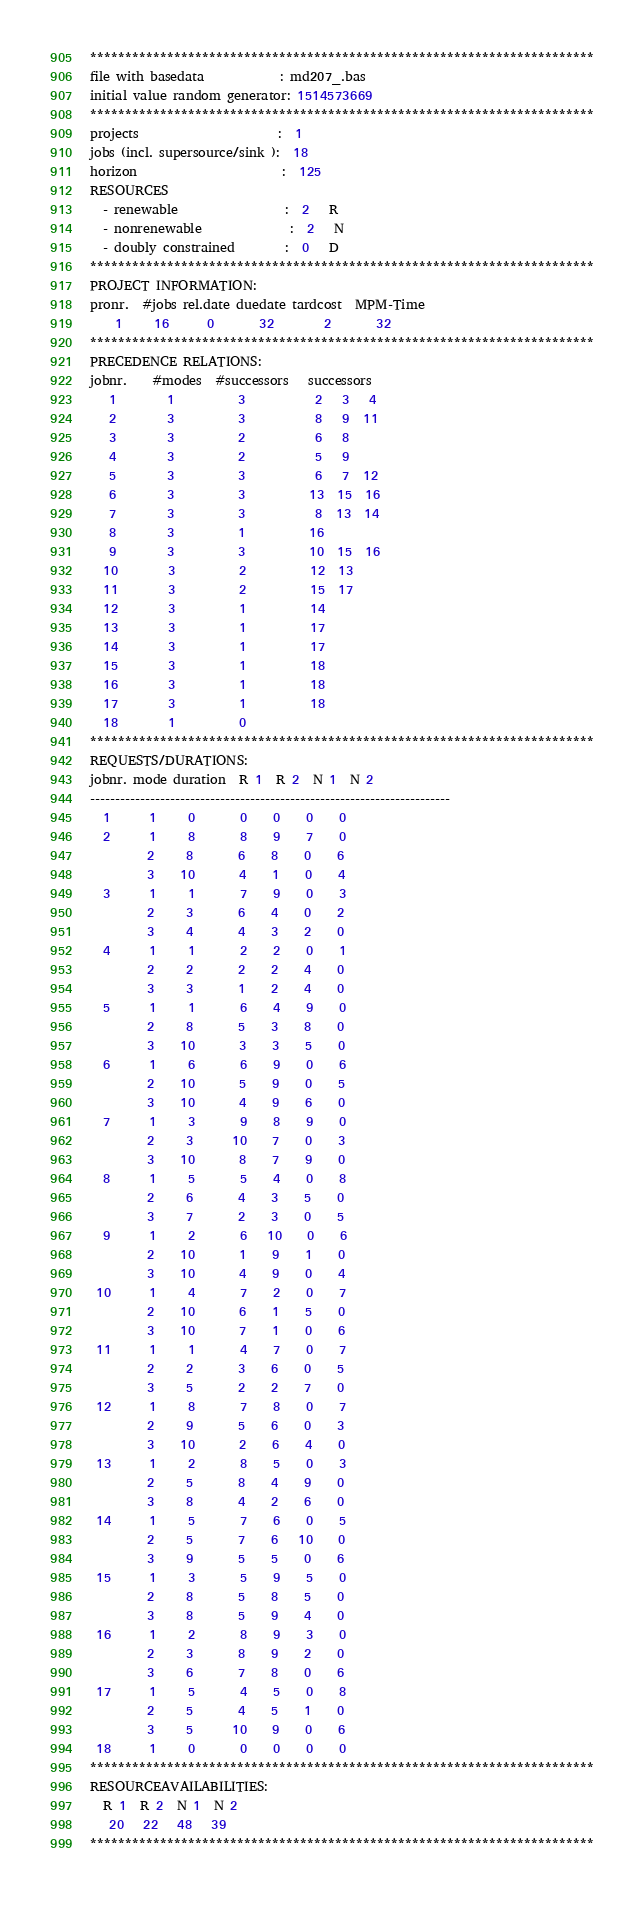<code> <loc_0><loc_0><loc_500><loc_500><_ObjectiveC_>************************************************************************
file with basedata            : md207_.bas
initial value random generator: 1514573669
************************************************************************
projects                      :  1
jobs (incl. supersource/sink ):  18
horizon                       :  125
RESOURCES
  - renewable                 :  2   R
  - nonrenewable              :  2   N
  - doubly constrained        :  0   D
************************************************************************
PROJECT INFORMATION:
pronr.  #jobs rel.date duedate tardcost  MPM-Time
    1     16      0       32        2       32
************************************************************************
PRECEDENCE RELATIONS:
jobnr.    #modes  #successors   successors
   1        1          3           2   3   4
   2        3          3           8   9  11
   3        3          2           6   8
   4        3          2           5   9
   5        3          3           6   7  12
   6        3          3          13  15  16
   7        3          3           8  13  14
   8        3          1          16
   9        3          3          10  15  16
  10        3          2          12  13
  11        3          2          15  17
  12        3          1          14
  13        3          1          17
  14        3          1          17
  15        3          1          18
  16        3          1          18
  17        3          1          18
  18        1          0        
************************************************************************
REQUESTS/DURATIONS:
jobnr. mode duration  R 1  R 2  N 1  N 2
------------------------------------------------------------------------
  1      1     0       0    0    0    0
  2      1     8       8    9    7    0
         2     8       6    8    0    6
         3    10       4    1    0    4
  3      1     1       7    9    0    3
         2     3       6    4    0    2
         3     4       4    3    2    0
  4      1     1       2    2    0    1
         2     2       2    2    4    0
         3     3       1    2    4    0
  5      1     1       6    4    9    0
         2     8       5    3    8    0
         3    10       3    3    5    0
  6      1     6       6    9    0    6
         2    10       5    9    0    5
         3    10       4    9    6    0
  7      1     3       9    8    9    0
         2     3      10    7    0    3
         3    10       8    7    9    0
  8      1     5       5    4    0    8
         2     6       4    3    5    0
         3     7       2    3    0    5
  9      1     2       6   10    0    6
         2    10       1    9    1    0
         3    10       4    9    0    4
 10      1     4       7    2    0    7
         2    10       6    1    5    0
         3    10       7    1    0    6
 11      1     1       4    7    0    7
         2     2       3    6    0    5
         3     5       2    2    7    0
 12      1     8       7    8    0    7
         2     9       5    6    0    3
         3    10       2    6    4    0
 13      1     2       8    5    0    3
         2     5       8    4    9    0
         3     8       4    2    6    0
 14      1     5       7    6    0    5
         2     5       7    6   10    0
         3     9       5    5    0    6
 15      1     3       5    9    5    0
         2     8       5    8    5    0
         3     8       5    9    4    0
 16      1     2       8    9    3    0
         2     3       8    9    2    0
         3     6       7    8    0    6
 17      1     5       4    5    0    8
         2     5       4    5    1    0
         3     5      10    9    0    6
 18      1     0       0    0    0    0
************************************************************************
RESOURCEAVAILABILITIES:
  R 1  R 2  N 1  N 2
   20   22   48   39
************************************************************************
</code> 